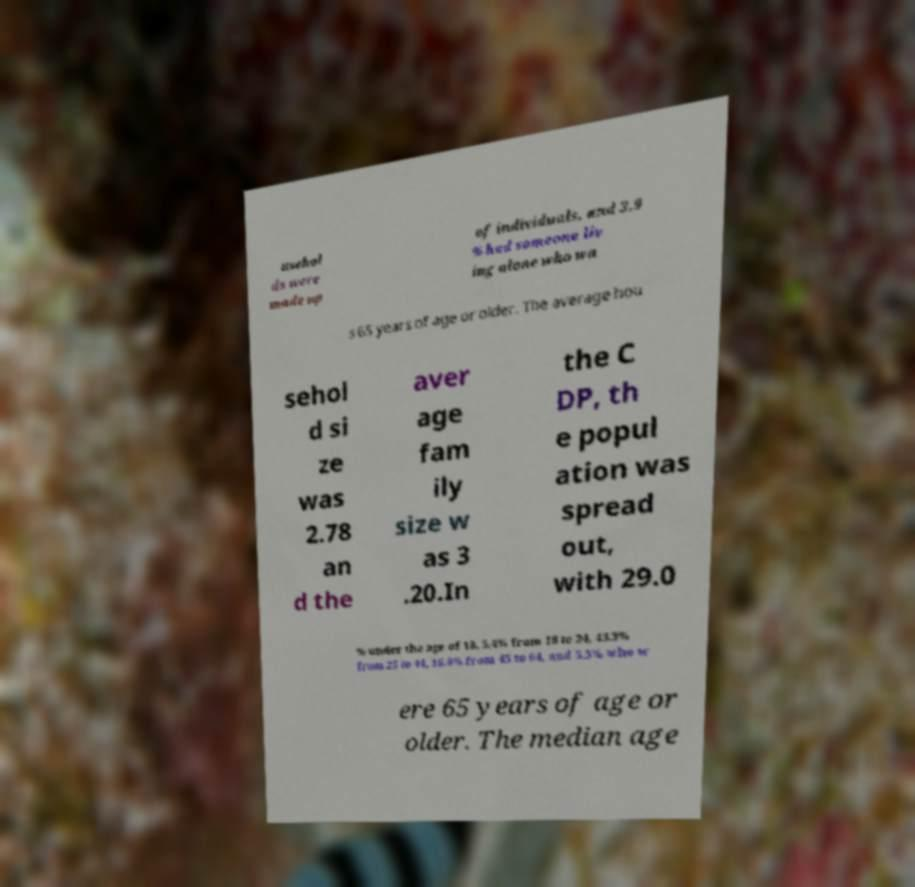What messages or text are displayed in this image? I need them in a readable, typed format. usehol ds were made up of individuals, and 3.9 % had someone liv ing alone who wa s 65 years of age or older. The average hou sehol d si ze was 2.78 an d the aver age fam ily size w as 3 .20.In the C DP, th e popul ation was spread out, with 29.0 % under the age of 18, 5.4% from 18 to 24, 43.3% from 25 to 44, 16.9% from 45 to 64, and 5.3% who w ere 65 years of age or older. The median age 